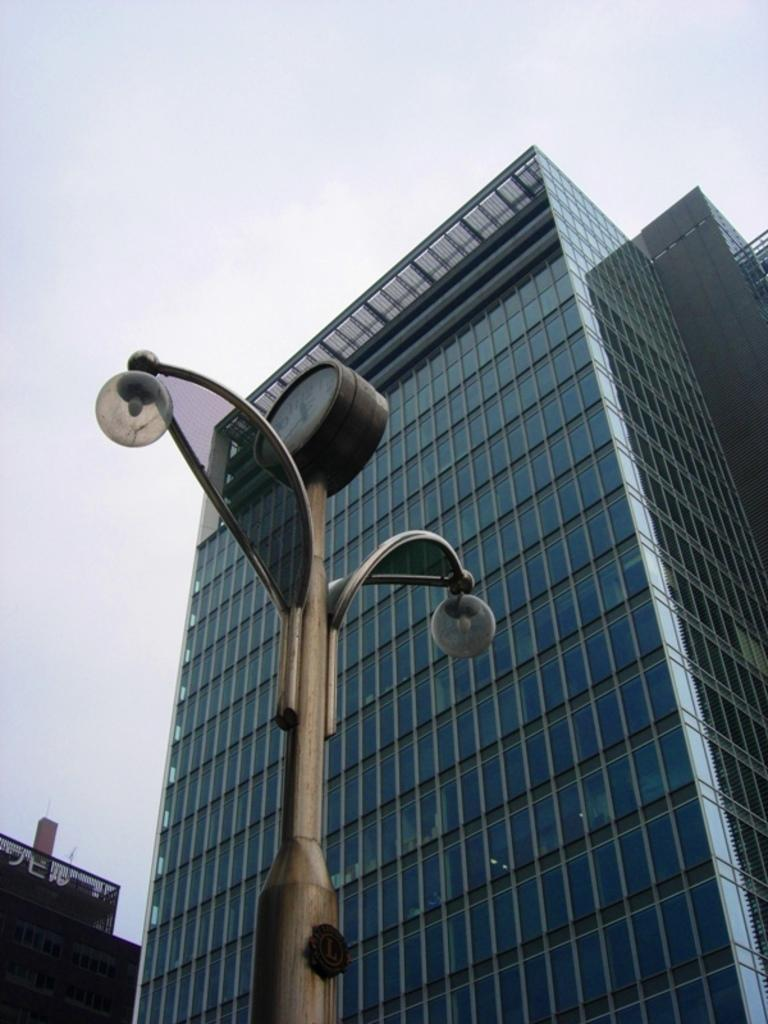What type of structures can be seen in the image? There are buildings in the image. What object is present in the image that is not a building? There is a pole in the image. What is attached to the pole? There are lights on the pole. How would you describe the sky in the image? The sky is cloudy in the image. What type of suit is the pole wearing in the image? The pole is not wearing a suit, as it is an inanimate object. 